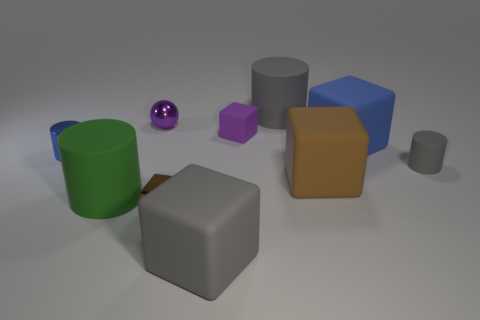Subtract all small gray cylinders. How many cylinders are left? 3 Subtract all spheres. How many objects are left? 9 Subtract all gray cylinders. How many cylinders are left? 2 Subtract 2 brown blocks. How many objects are left? 8 Subtract 3 cylinders. How many cylinders are left? 1 Subtract all green spheres. Subtract all yellow cylinders. How many spheres are left? 1 Subtract all yellow spheres. How many green cylinders are left? 1 Subtract all green cylinders. Subtract all small blue objects. How many objects are left? 8 Add 1 big gray cylinders. How many big gray cylinders are left? 2 Add 6 small purple spheres. How many small purple spheres exist? 7 